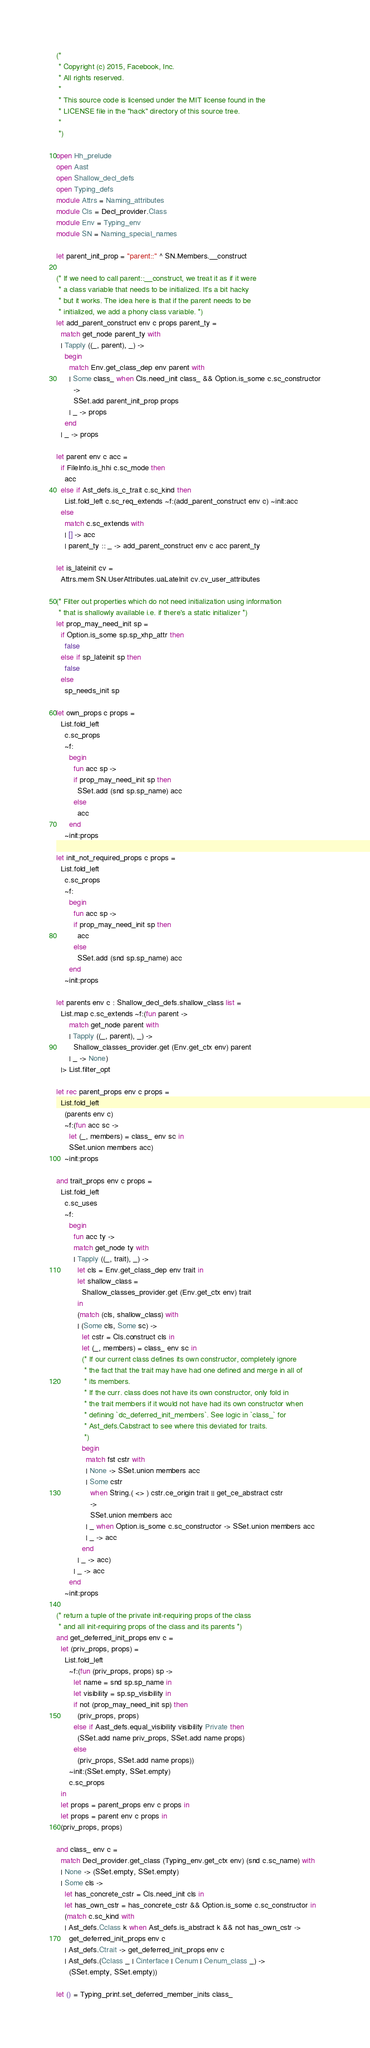Convert code to text. <code><loc_0><loc_0><loc_500><loc_500><_OCaml_>(*
 * Copyright (c) 2015, Facebook, Inc.
 * All rights reserved.
 *
 * This source code is licensed under the MIT license found in the
 * LICENSE file in the "hack" directory of this source tree.
 *
 *)

open Hh_prelude
open Aast
open Shallow_decl_defs
open Typing_defs
module Attrs = Naming_attributes
module Cls = Decl_provider.Class
module Env = Typing_env
module SN = Naming_special_names

let parent_init_prop = "parent::" ^ SN.Members.__construct

(* If we need to call parent::__construct, we treat it as if it were
 * a class variable that needs to be initialized. It's a bit hacky
 * but it works. The idea here is that if the parent needs to be
 * initialized, we add a phony class variable. *)
let add_parent_construct env c props parent_ty =
  match get_node parent_ty with
  | Tapply ((_, parent), _) ->
    begin
      match Env.get_class_dep env parent with
      | Some class_ when Cls.need_init class_ && Option.is_some c.sc_constructor
        ->
        SSet.add parent_init_prop props
      | _ -> props
    end
  | _ -> props

let parent env c acc =
  if FileInfo.is_hhi c.sc_mode then
    acc
  else if Ast_defs.is_c_trait c.sc_kind then
    List.fold_left c.sc_req_extends ~f:(add_parent_construct env c) ~init:acc
  else
    match c.sc_extends with
    | [] -> acc
    | parent_ty :: _ -> add_parent_construct env c acc parent_ty

let is_lateinit cv =
  Attrs.mem SN.UserAttributes.uaLateInit cv.cv_user_attributes

(* Filter out properties which do not need initialization using information
 * that is shallowly available i.e. if there's a static initializer *)
let prop_may_need_init sp =
  if Option.is_some sp.sp_xhp_attr then
    false
  else if sp_lateinit sp then
    false
  else
    sp_needs_init sp

let own_props c props =
  List.fold_left
    c.sc_props
    ~f:
      begin
        fun acc sp ->
        if prop_may_need_init sp then
          SSet.add (snd sp.sp_name) acc
        else
          acc
      end
    ~init:props

let init_not_required_props c props =
  List.fold_left
    c.sc_props
    ~f:
      begin
        fun acc sp ->
        if prop_may_need_init sp then
          acc
        else
          SSet.add (snd sp.sp_name) acc
      end
    ~init:props

let parents env c : Shallow_decl_defs.shallow_class list =
  List.map c.sc_extends ~f:(fun parent ->
      match get_node parent with
      | Tapply ((_, parent), _) ->
        Shallow_classes_provider.get (Env.get_ctx env) parent
      | _ -> None)
  |> List.filter_opt

let rec parent_props env c props =
  List.fold_left
    (parents env c)
    ~f:(fun acc sc ->
      let (_, members) = class_ env sc in
      SSet.union members acc)
    ~init:props

and trait_props env c props =
  List.fold_left
    c.sc_uses
    ~f:
      begin
        fun acc ty ->
        match get_node ty with
        | Tapply ((_, trait), _) ->
          let cls = Env.get_class_dep env trait in
          let shallow_class =
            Shallow_classes_provider.get (Env.get_ctx env) trait
          in
          (match (cls, shallow_class) with
          | (Some cls, Some sc) ->
            let cstr = Cls.construct cls in
            let (_, members) = class_ env sc in
            (* If our current class defines its own constructor, completely ignore
             * the fact that the trait may have had one defined and merge in all of
             * its members.
             * If the curr. class does not have its own constructor, only fold in
             * the trait members if it would not have had its own constructor when
             * defining `dc_deferred_init_members`. See logic in `class_` for
             * Ast_defs.Cabstract to see where this deviated for traits.
             *)
            begin
              match fst cstr with
              | None -> SSet.union members acc
              | Some cstr
                when String.( <> ) cstr.ce_origin trait || get_ce_abstract cstr
                ->
                SSet.union members acc
              | _ when Option.is_some c.sc_constructor -> SSet.union members acc
              | _ -> acc
            end
          | _ -> acc)
        | _ -> acc
      end
    ~init:props

(* return a tuple of the private init-requiring props of the class
 * and all init-requiring props of the class and its parents *)
and get_deferred_init_props env c =
  let (priv_props, props) =
    List.fold_left
      ~f:(fun (priv_props, props) sp ->
        let name = snd sp.sp_name in
        let visibility = sp.sp_visibility in
        if not (prop_may_need_init sp) then
          (priv_props, props)
        else if Aast_defs.equal_visibility visibility Private then
          (SSet.add name priv_props, SSet.add name props)
        else
          (priv_props, SSet.add name props))
      ~init:(SSet.empty, SSet.empty)
      c.sc_props
  in
  let props = parent_props env c props in
  let props = parent env c props in
  (priv_props, props)

and class_ env c =
  match Decl_provider.get_class (Typing_env.get_ctx env) (snd c.sc_name) with
  | None -> (SSet.empty, SSet.empty)
  | Some cls ->
    let has_concrete_cstr = Cls.need_init cls in
    let has_own_cstr = has_concrete_cstr && Option.is_some c.sc_constructor in
    (match c.sc_kind with
    | Ast_defs.Cclass k when Ast_defs.is_abstract k && not has_own_cstr ->
      get_deferred_init_props env c
    | Ast_defs.Ctrait -> get_deferred_init_props env c
    | Ast_defs.(Cclass _ | Cinterface | Cenum | Cenum_class _) ->
      (SSet.empty, SSet.empty))

let () = Typing_print.set_deferred_member_inits class_
</code> 